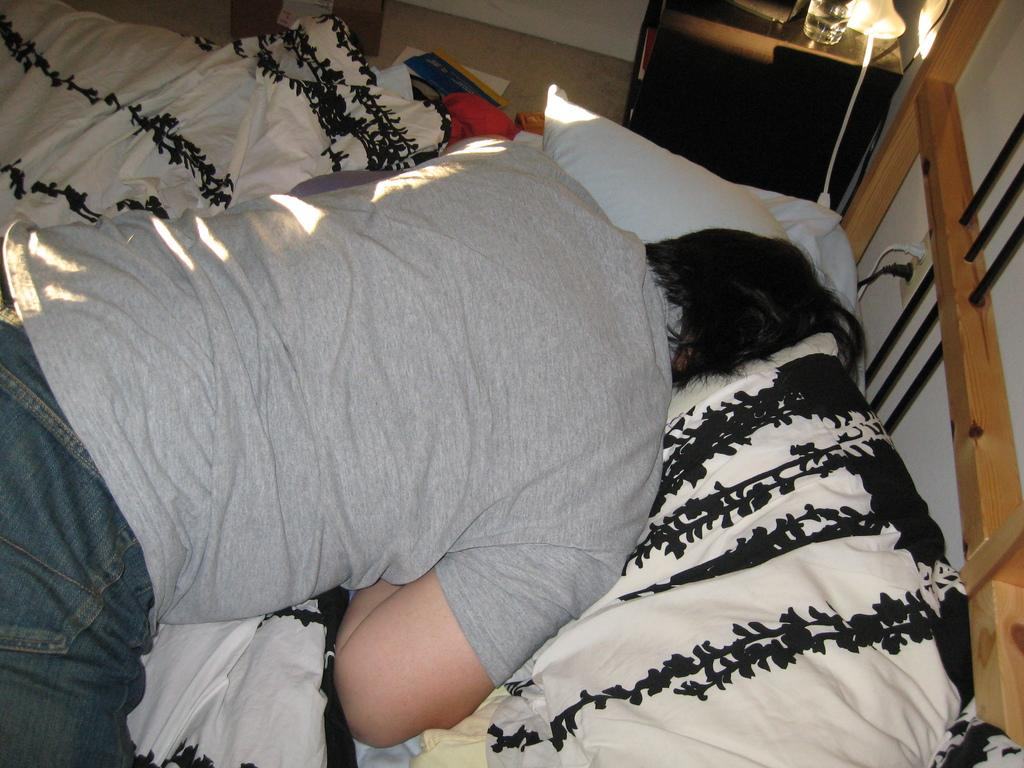What type of room is shown in the image? The image depicts a bedroom. What is the man in the image doing? The man is laying on the bed and sleeping. What can be seen in the background of the image? There is a lamp and a wall in the background. What type of steel object can be seen on the ground in the image? There is no steel object present on the ground in the image. 